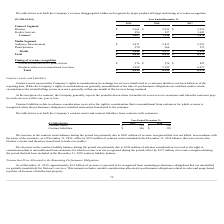According to Nielsen Nv's financial document, What was the cause of the increase in the contract assets balance? due to $203 million of revenue recognized that was not billed, in accordance with the terms of the contracts, as of December 31, 2019, offset by $193 million of contract assets included in the December 31, 2018 balance that were invoiced to Nielsen’s clients and therefore transferred to trade receivables. The document states: "ct assets balance during the period was primarily due to $203 million of revenue recognized that was not billed, in accordance with the terms of the c..." Also, What was the cause of the decrease in contract liability balance? due to $326 million of advance consideration received or the right to consideration that is unconditional from customers for which revenue was not recognized during the period, offset by $337 million of revenue recognized during the period that had been included in the December 31, 2018 contract liability balance. The document states: "liability balance during the period was primarily due to $326 million of advance consideration received or the right to consideration that is uncondit..." Also, What is the contract assets for the year ended December 31, 2019? According to the financial document, 218 (in millions). The relevant text states: "Contract assets $ 218 $ 210..." Also, can you calculate: What is the percentage change in the contract assets from 2018 to 2019? To answer this question, I need to perform calculations using the financial data. The calculation is: (218-210)/210, which equals 3.81 (percentage). This is based on the information: "Contract assets $ 218 $ 210 Contract assets $ 218 $ 210..." The key data points involved are: 210, 218. Also, can you calculate: What is the percentage change in the contract liabilities from 2018 to 2019? To answer this question, I need to perform calculations using the financial data. The calculation is: (346-359)/359, which equals -3.62 (percentage). This is based on the information: "Contract liabilities $ 346 $ 359 Contract liabilities $ 346 $ 359..." The key data points involved are: 346, 359. Also, can you calculate: What is the change in the contract assets from 2018 to 2019? Based on the calculation: 218-210, the result is 8 (in millions). This is based on the information: "Contract assets $ 218 $ 210 Contract assets $ 218 $ 210..." The key data points involved are: 210, 218. 